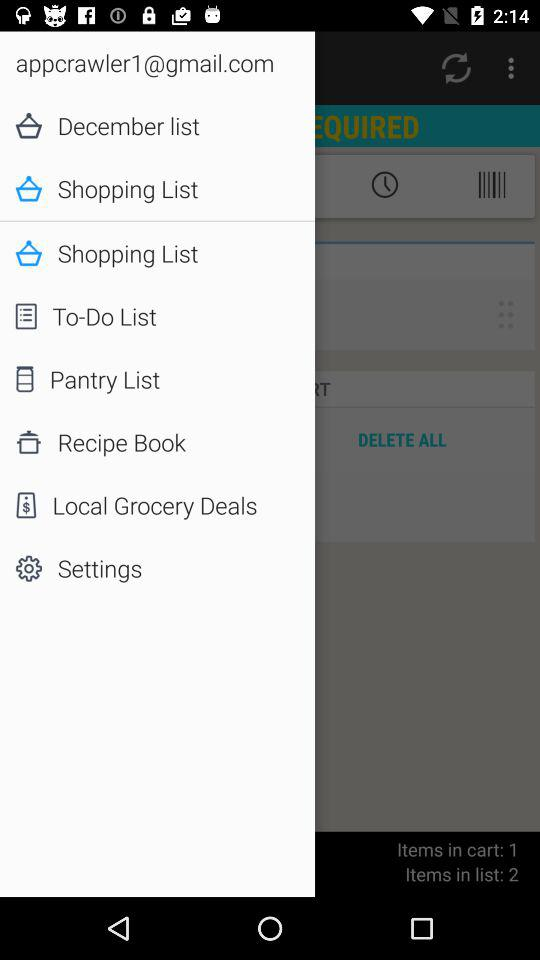What is the email address? The email address is appcrawler1@gmail.com. 